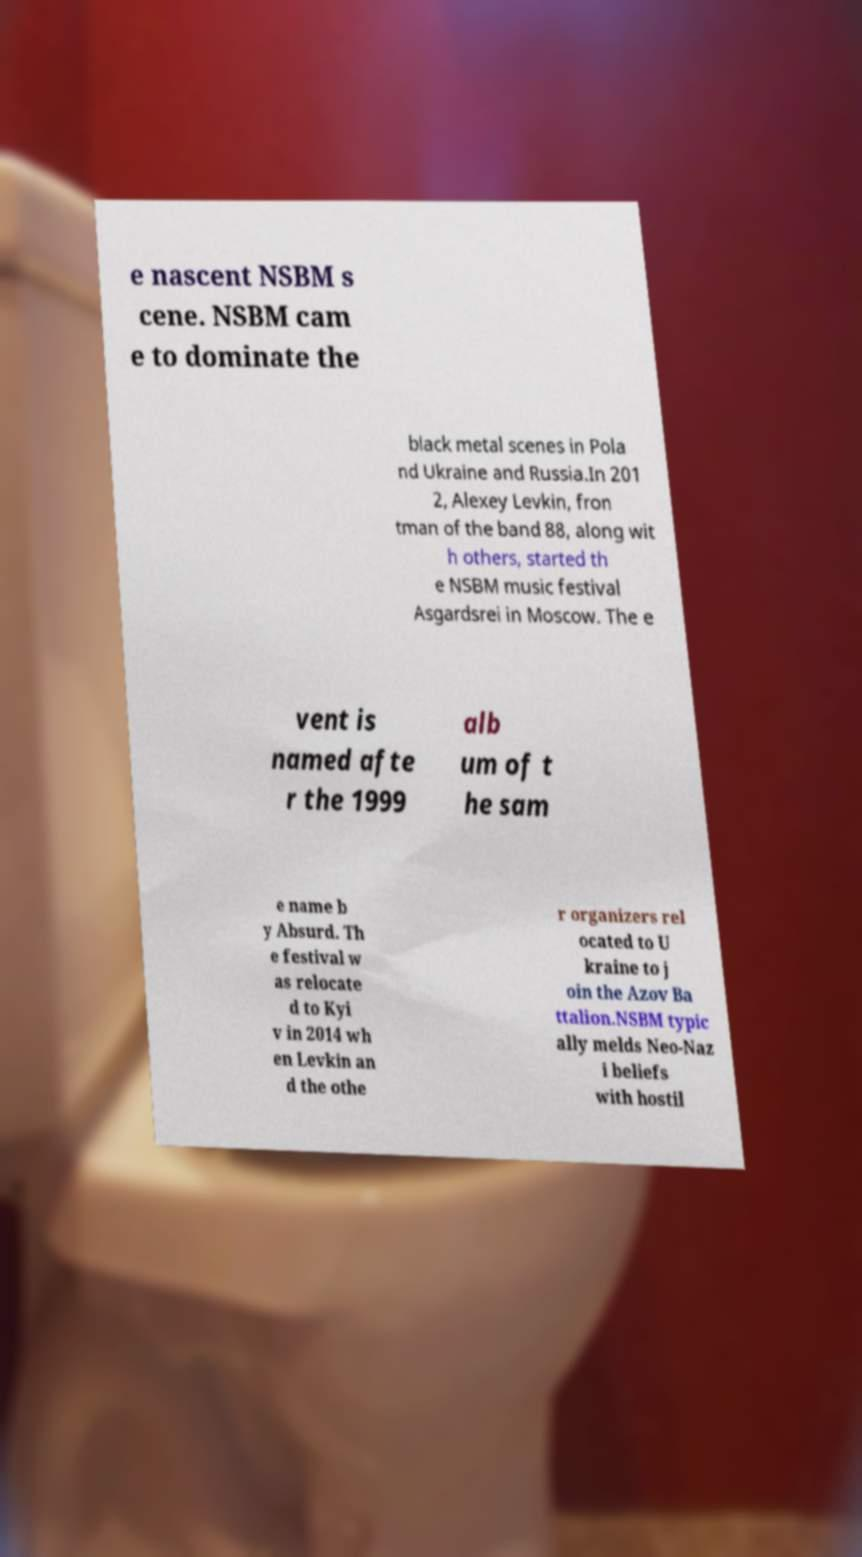Please read and relay the text visible in this image. What does it say? e nascent NSBM s cene. NSBM cam e to dominate the black metal scenes in Pola nd Ukraine and Russia.In 201 2, Alexey Levkin, fron tman of the band 88, along wit h others, started th e NSBM music festival Asgardsrei in Moscow. The e vent is named afte r the 1999 alb um of t he sam e name b y Absurd. Th e festival w as relocate d to Kyi v in 2014 wh en Levkin an d the othe r organizers rel ocated to U kraine to j oin the Azov Ba ttalion.NSBM typic ally melds Neo-Naz i beliefs with hostil 